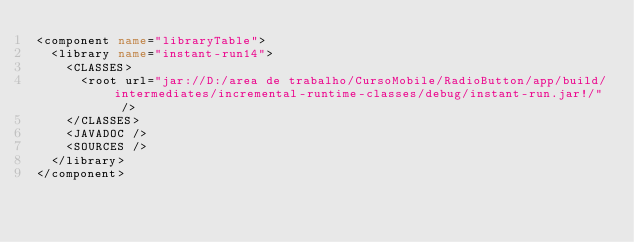Convert code to text. <code><loc_0><loc_0><loc_500><loc_500><_XML_><component name="libraryTable">
  <library name="instant-run14">
    <CLASSES>
      <root url="jar://D:/area de trabalho/CursoMobile/RadioButton/app/build/intermediates/incremental-runtime-classes/debug/instant-run.jar!/" />
    </CLASSES>
    <JAVADOC />
    <SOURCES />
  </library>
</component></code> 